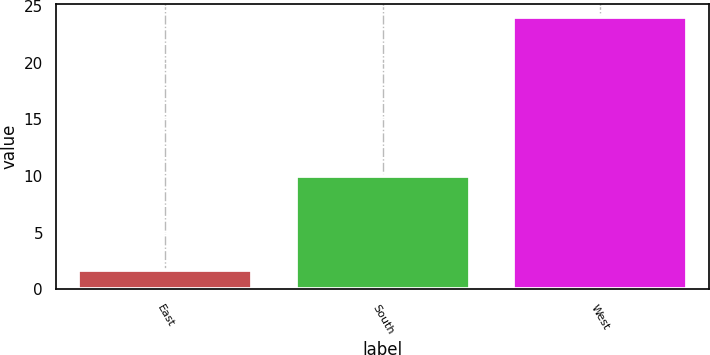<chart> <loc_0><loc_0><loc_500><loc_500><bar_chart><fcel>East<fcel>South<fcel>West<nl><fcel>1.74<fcel>10<fcel>24<nl></chart> 